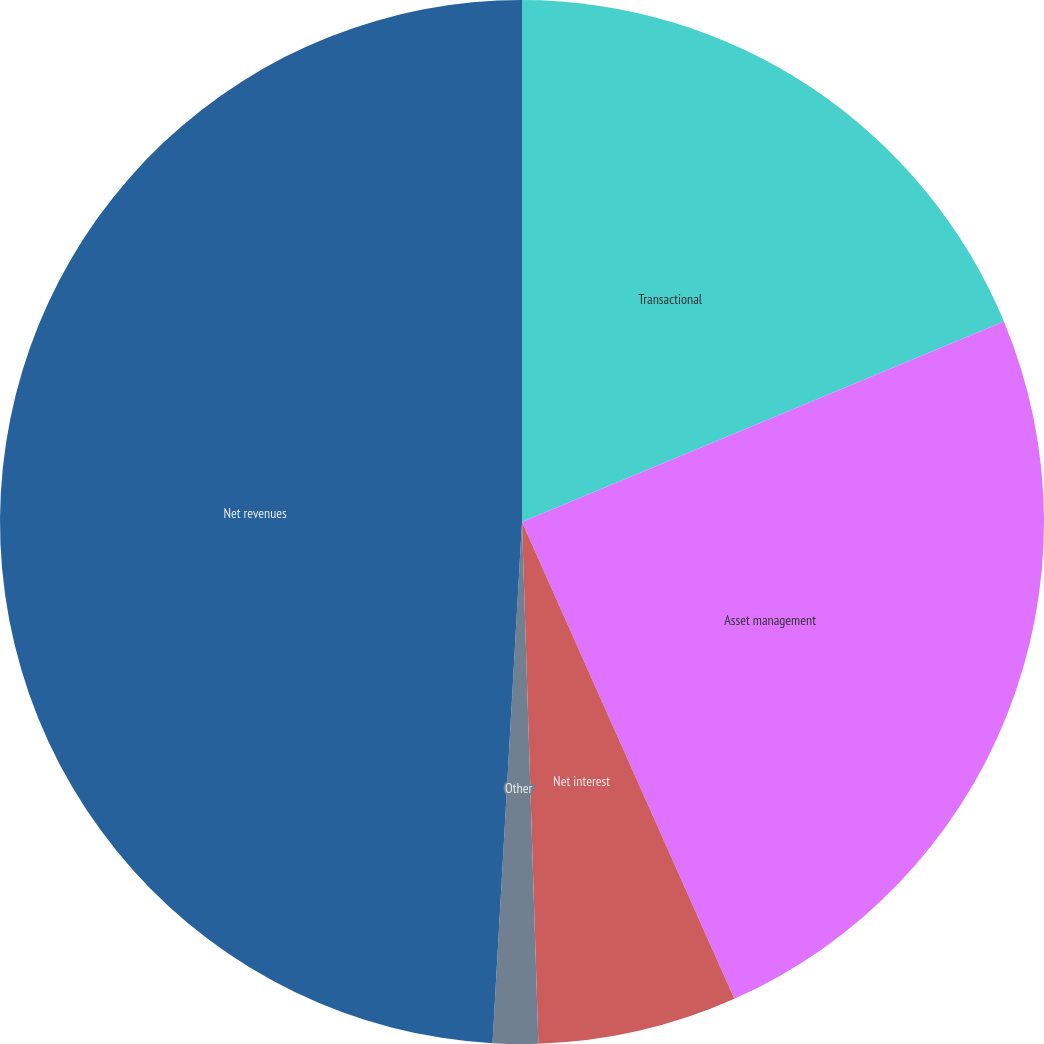Convert chart to OTSL. <chart><loc_0><loc_0><loc_500><loc_500><pie_chart><fcel>Transactional<fcel>Asset management<fcel>Net interest<fcel>Other<fcel>Net revenues<nl><fcel>18.73%<fcel>24.61%<fcel>6.17%<fcel>1.4%<fcel>49.11%<nl></chart> 